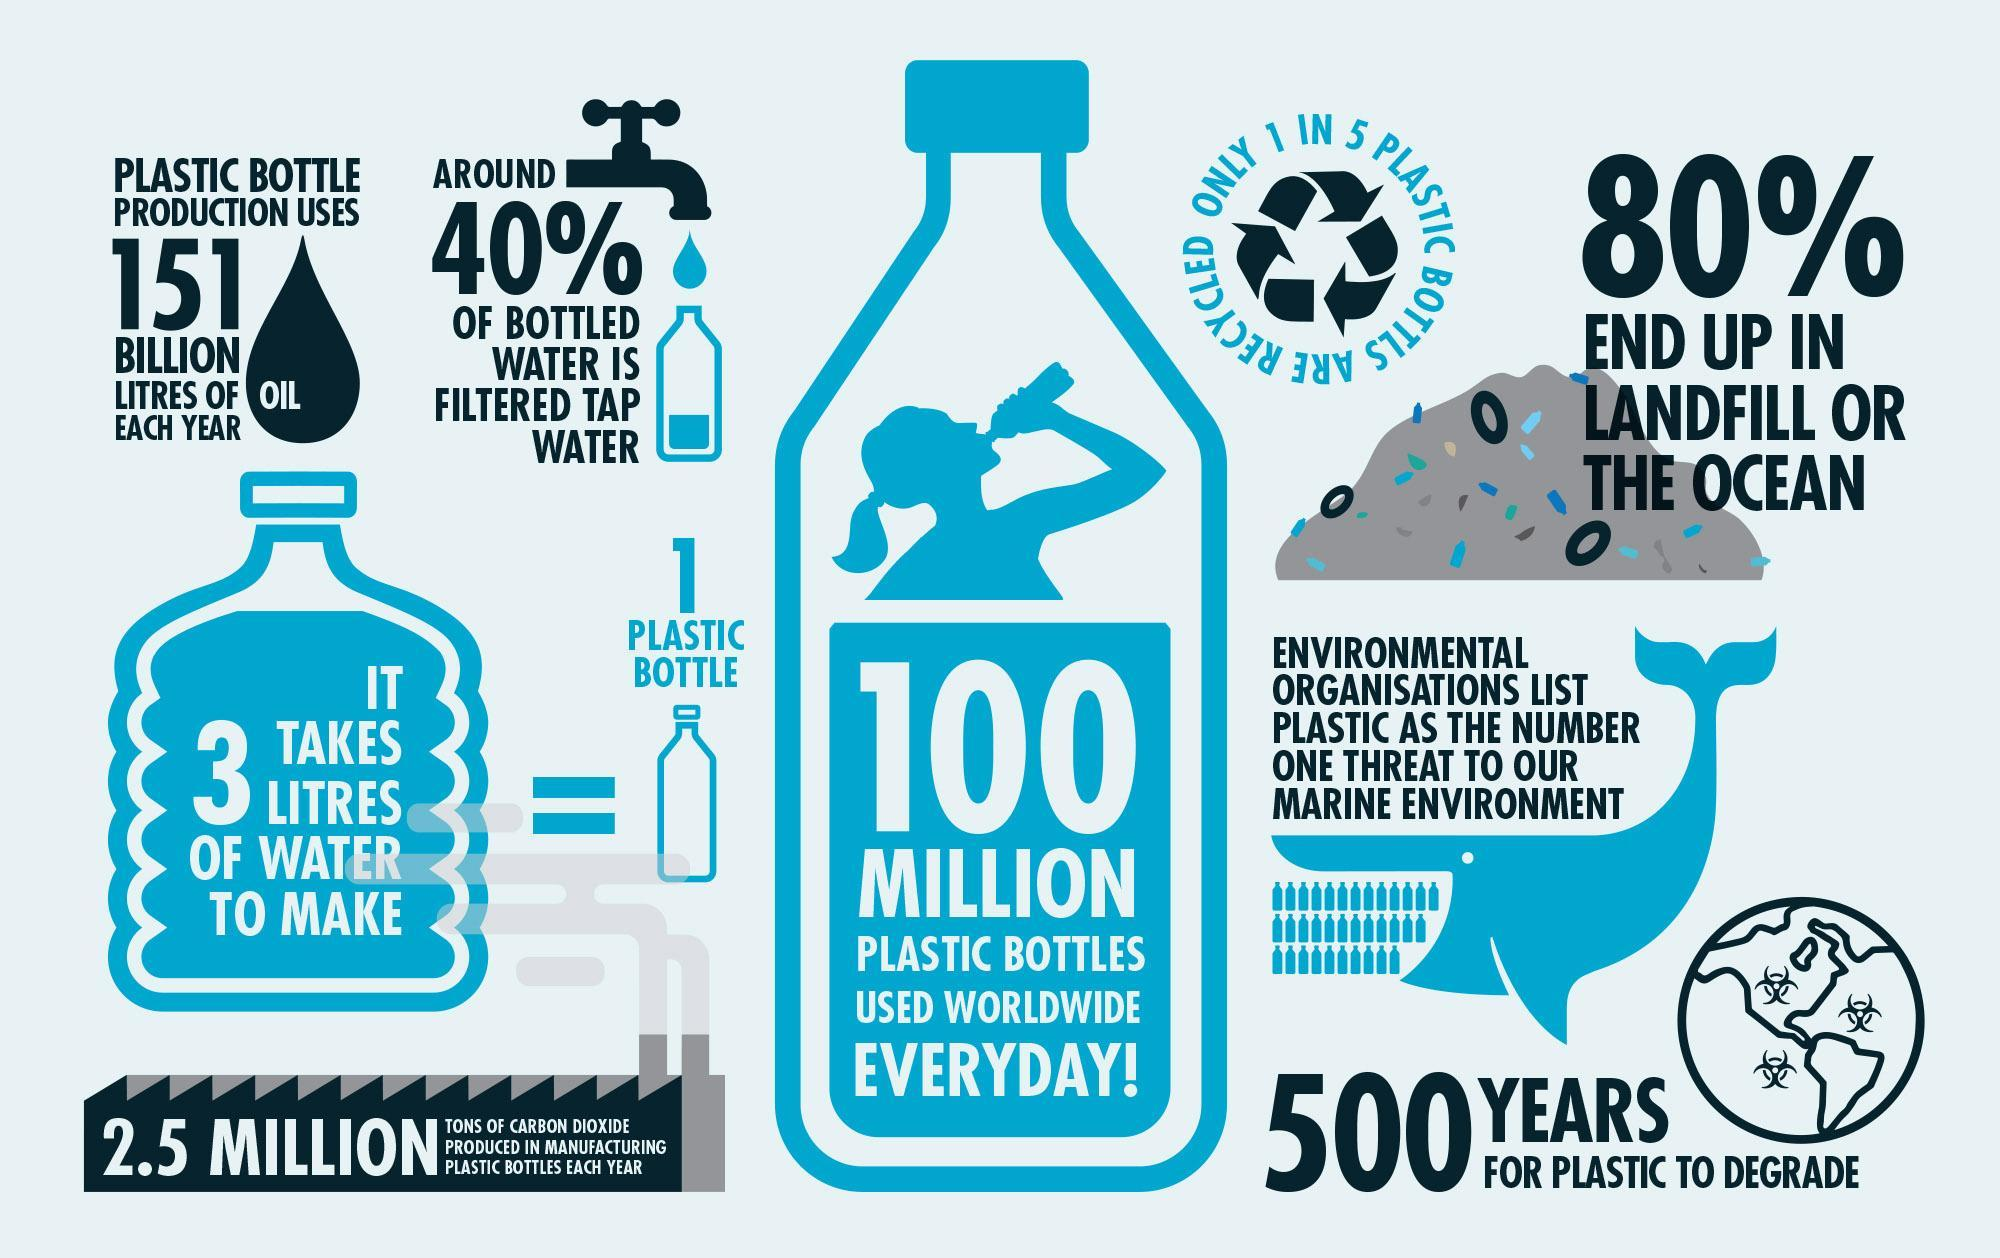What percentage of bottled water is not filtered tap water?
Answer the question with a short phrase. 60% Out of 5, how many plastic bottles not recycled? 4 How many plastic bottles used worldwide every day? 100 million 